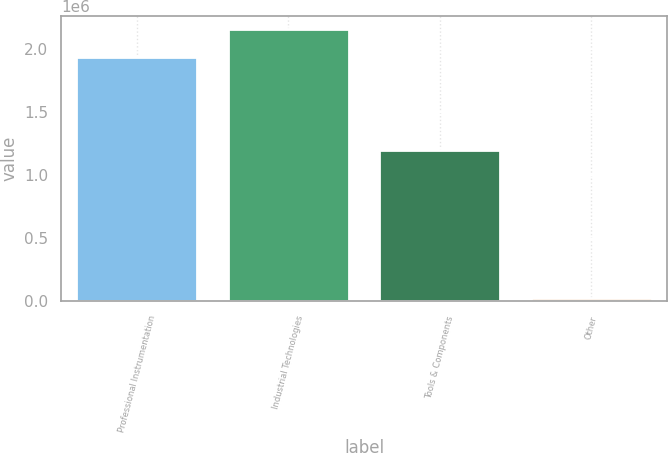<chart> <loc_0><loc_0><loc_500><loc_500><bar_chart><fcel>Professional Instrumentation<fcel>Industrial Technologies<fcel>Tools & Components<fcel>Other<nl><fcel>1.93966e+06<fcel>2.15703e+06<fcel>1.19719e+06<fcel>24669<nl></chart> 